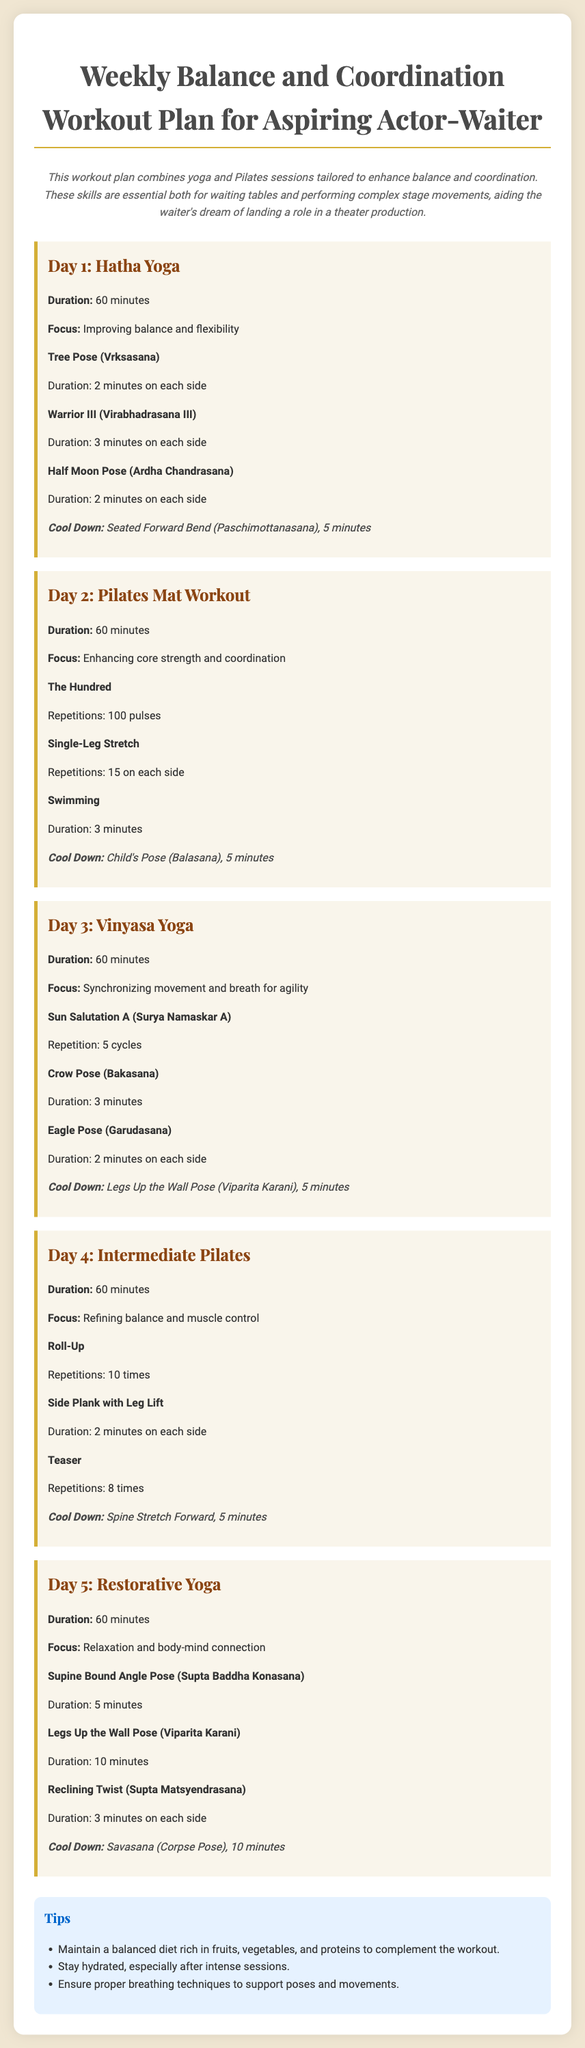What is the duration of Day 1's workout? The duration of Day 1's workout is mentioned as 60 minutes.
Answer: 60 minutes What yoga poses are included in Day 1? Day 1 includes Tree Pose, Warrior III, and Half Moon Pose, all detailed in the document.
Answer: Tree Pose, Warrior III, Half Moon Pose How many repetitions are suggested for The Hundred exercise? The number of repetitions suggested for The Hundred exercise is clearly stated in the document.
Answer: 100 pulses What is the focus of Day 3's workout? The focus of Day 3's workout is specified as synchronizing movement and breath for agility.
Answer: Synchronizing movement and breath for agility Which type of yoga is practiced on Day 5? The type of yoga practiced on Day 5 is indicated as Restorative Yoga.
Answer: Restorative Yoga What is the total duration for cool down on Day 4? The cool down time for Day 4 consists of a single exercise lasting 5 minutes.
Answer: 5 minutes Which exercises are included in the Pilates session on Day 2? The exercises in Day 2's Pilates session include The Hundred, Single-Leg Stretch, and Swimming.
Answer: The Hundred, Single-Leg Stretch, Swimming What should be maintained along with the workout? The document suggests maintaining a balanced diet rich in fruits, vegetables, and proteins.
Answer: Balanced diet How long should one hold the Supine Bound Angle Pose? The duration for holding the Supine Bound Angle Pose is mentioned in the document as 5 minutes.
Answer: 5 minutes 